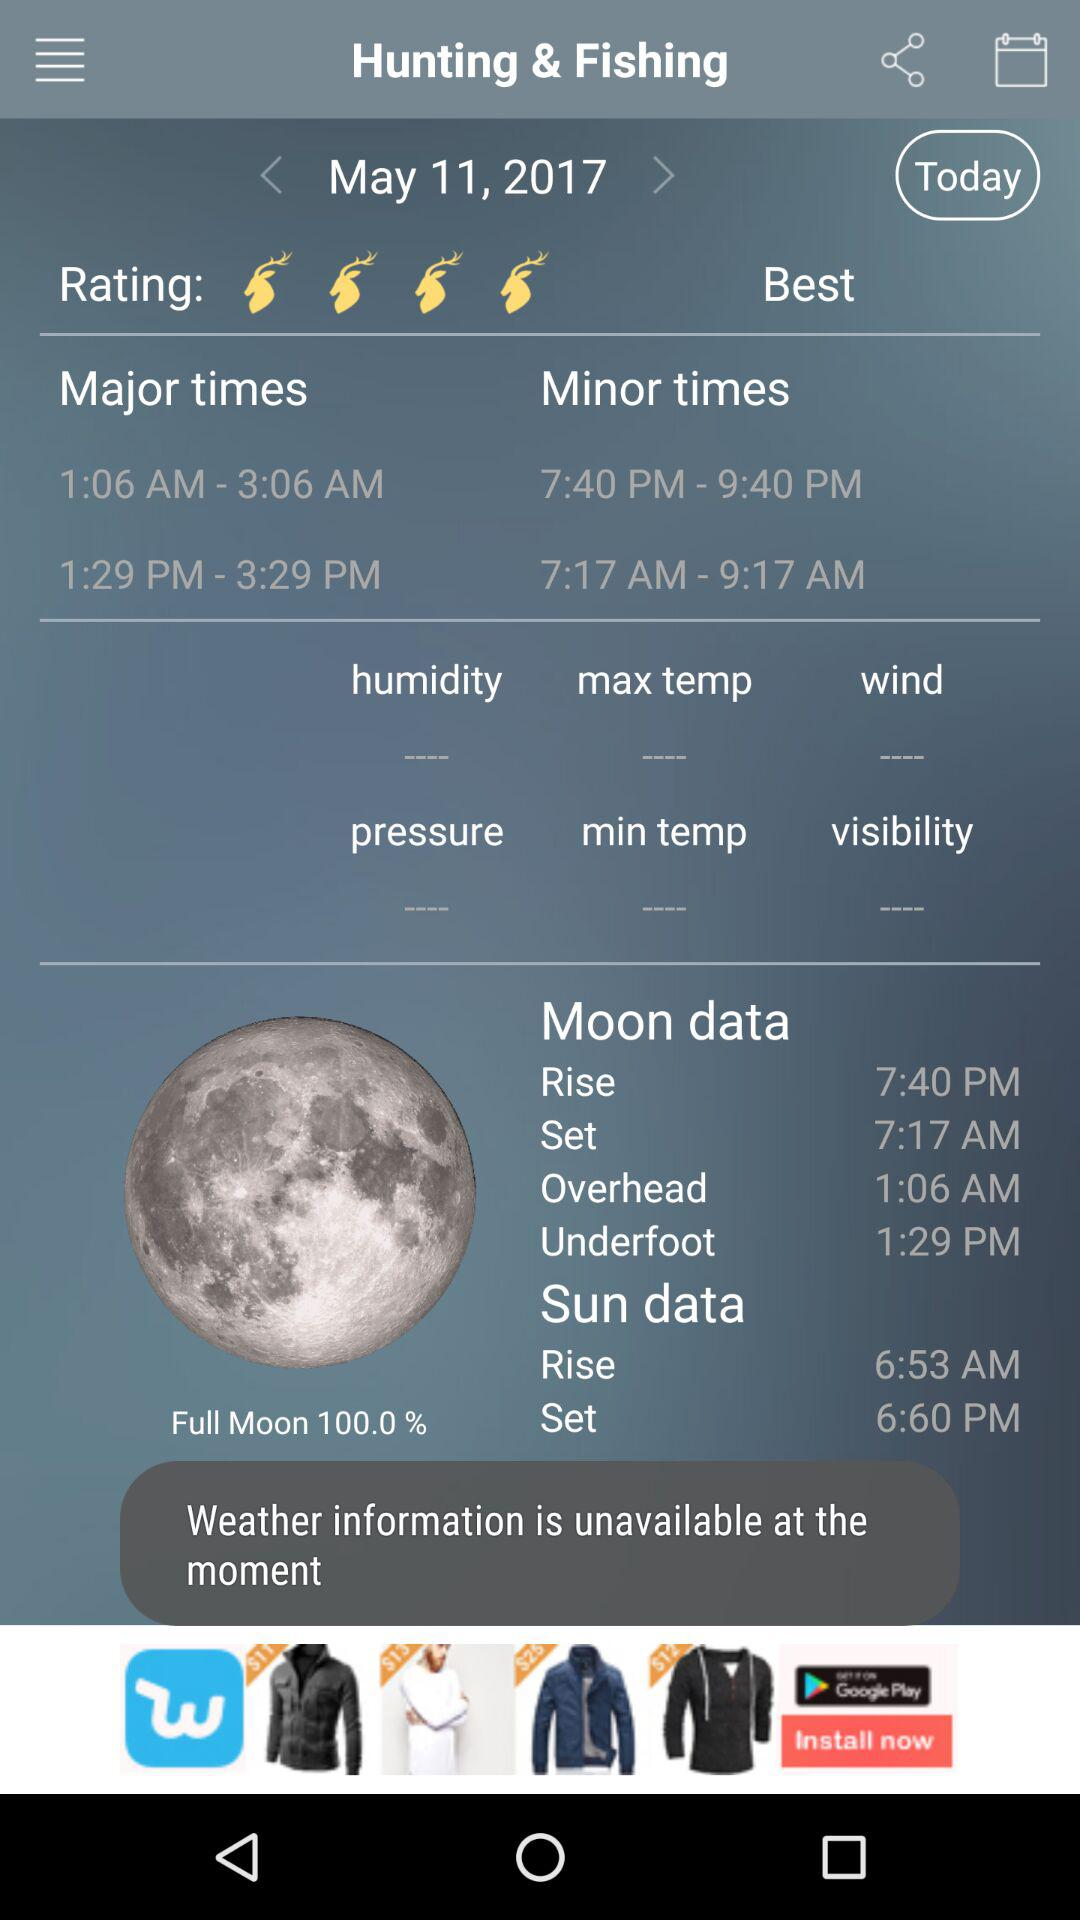When will the moon rise? The moon will rise at 7:40 p.m. 